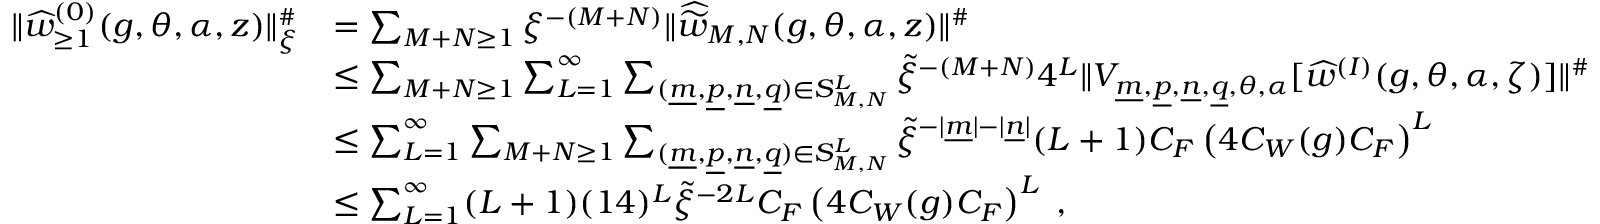Convert formula to latex. <formula><loc_0><loc_0><loc_500><loc_500>\begin{array} { r l } { \| \widehat { w } _ { \geq 1 } ^ { ( 0 ) } ( g , \theta , \alpha , z ) \| _ { \xi } ^ { \# } } & { = \sum _ { M + N \geq 1 } { \xi } ^ { - ( M + N ) } \| \widehat { \widetilde { w } } _ { M , N } ( g , \theta , \alpha , z ) \| ^ { \# } } \\ & { \leq \sum _ { M + N \geq 1 } \sum _ { L = 1 } ^ { \infty } \sum _ { ( \underline { m } , \underline { p } , \underline { n } , \underline { q } ) \in S _ { M , N } ^ { L } } \widetilde { \xi } ^ { - ( M + N ) } 4 ^ { L } \| V _ { \underline { m } , \underline { p } , \underline { n } , \underline { q } , \theta , \alpha } [ \widehat { w } ^ { ( I ) } ( g , \theta , \alpha , \zeta ) ] \| ^ { \# } } \\ & { \leq \sum _ { L = 1 } ^ { \infty } \sum _ { M + N \geq 1 } \sum _ { ( \underline { m } , \underline { p } , \underline { n } , \underline { q } ) \in S _ { M , N } ^ { L } } \widetilde { \xi } ^ { - | \underline { m } | - | \underline { n } | } ( L + 1 ) C _ { F } \left ( 4 C _ { W } ( g ) C _ { F } \right ) ^ { L } } \\ & { \leq \sum _ { L = 1 } ^ { \infty } ( L + 1 ) ( 1 4 ) ^ { L } \widetilde { \xi } ^ { - 2 L } C _ { F } \left ( 4 C _ { W } ( g ) C _ { F } \right ) ^ { L } \, , } \end{array}</formula> 